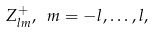<formula> <loc_0><loc_0><loc_500><loc_500>Z _ { l m } ^ { + } , \ m = - l , \dots , l ,</formula> 